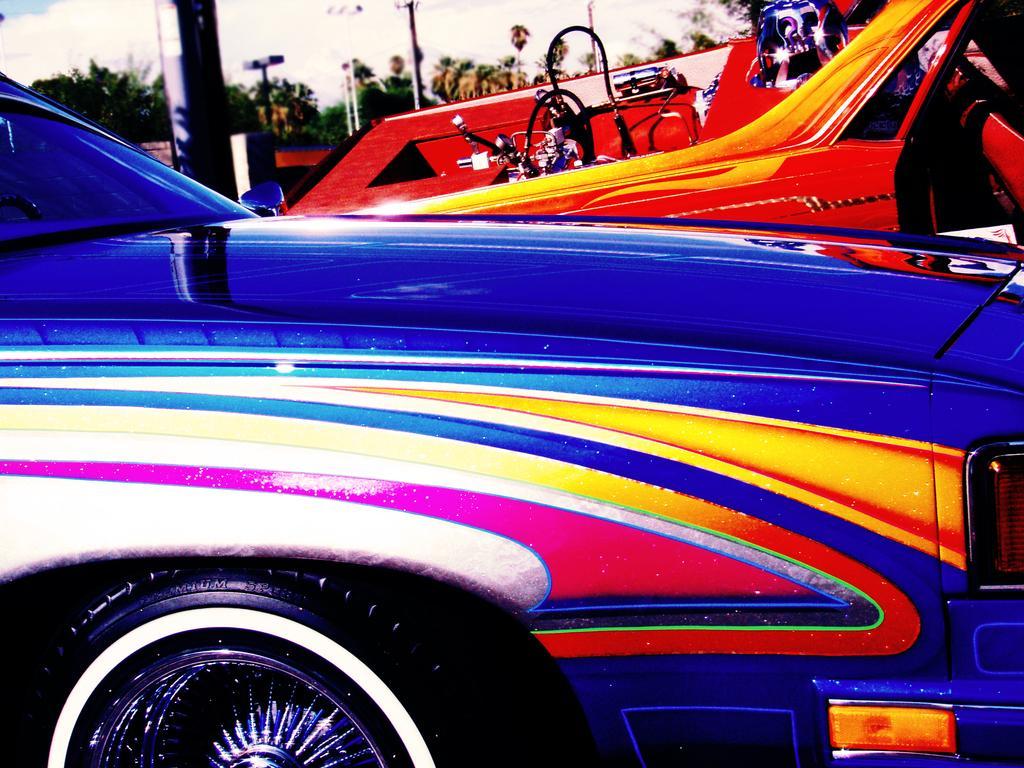Describe this image in one or two sentences. In this image I can see two cars with full of colors. I can see a bike and a person on the bike wearing helmet. I can see some trees, Poles and sky at the top of the image. 